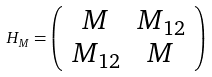<formula> <loc_0><loc_0><loc_500><loc_500>H _ { M } = \left ( \begin{array} { c c } M & M _ { 1 2 } \\ M _ { 1 2 } & M \end{array} \right )</formula> 